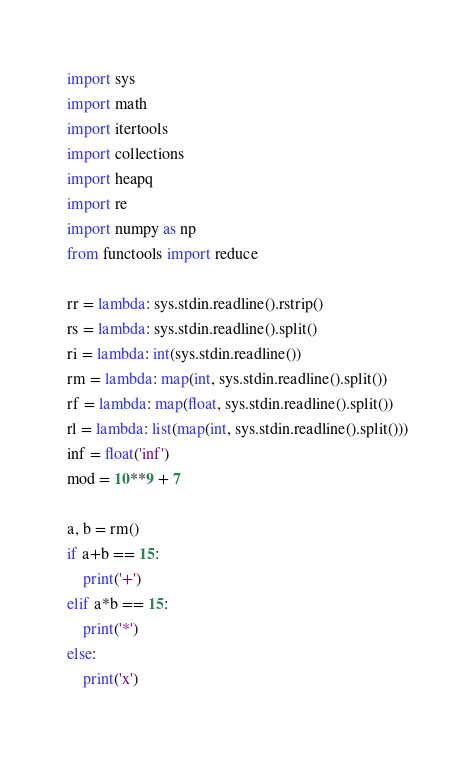<code> <loc_0><loc_0><loc_500><loc_500><_Python_>import sys
import math
import itertools
import collections
import heapq
import re
import numpy as np
from functools import reduce

rr = lambda: sys.stdin.readline().rstrip()
rs = lambda: sys.stdin.readline().split()
ri = lambda: int(sys.stdin.readline())
rm = lambda: map(int, sys.stdin.readline().split())
rf = lambda: map(float, sys.stdin.readline().split())
rl = lambda: list(map(int, sys.stdin.readline().split()))
inf = float('inf')
mod = 10**9 + 7

a, b = rm()
if a+b == 15:
    print('+')
elif a*b == 15:
    print('*')
else:
    print('x')</code> 